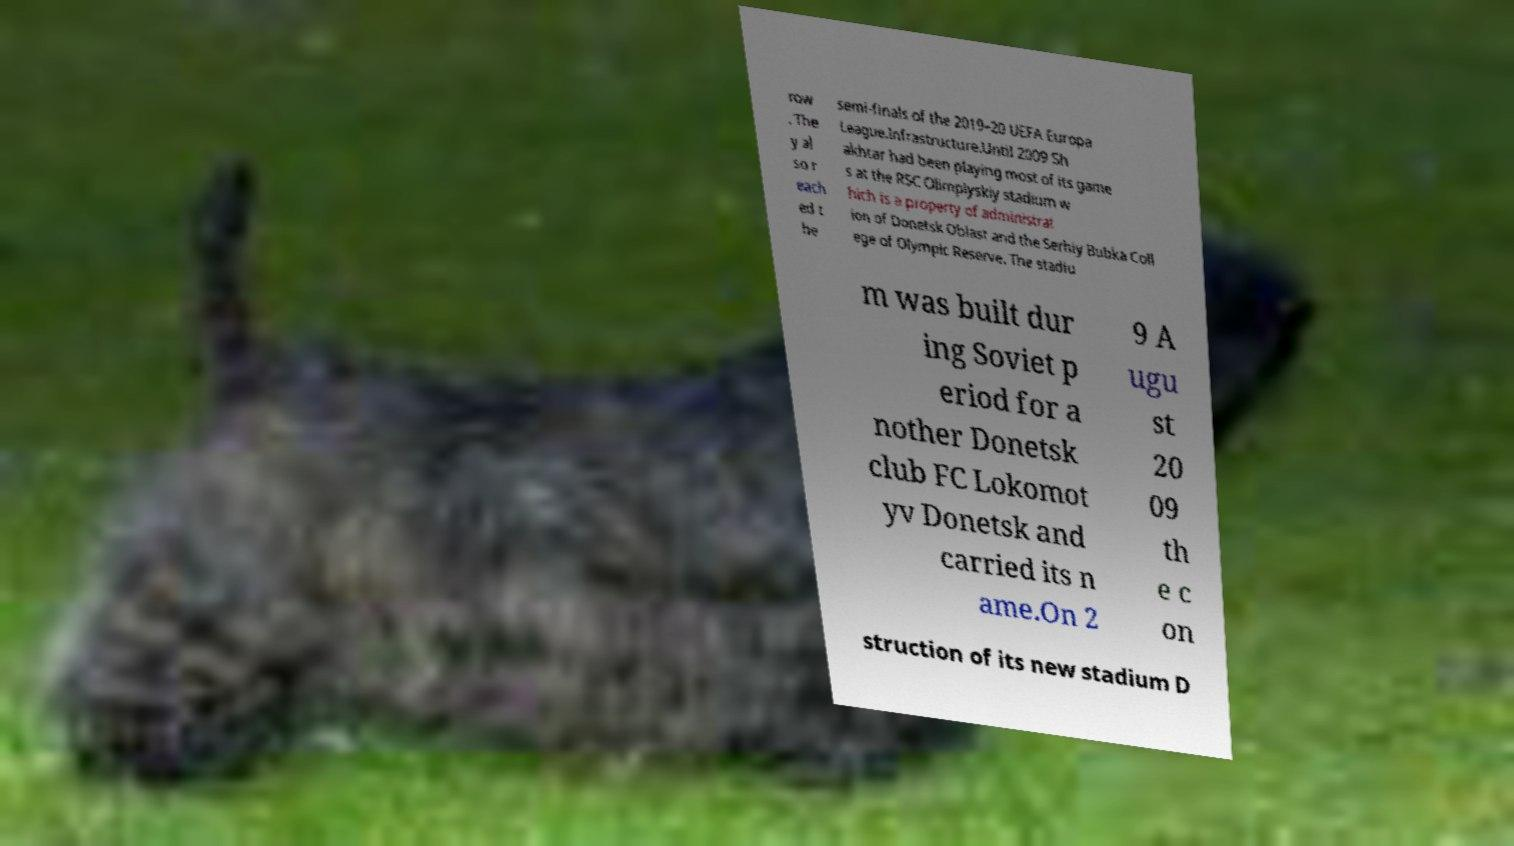Please read and relay the text visible in this image. What does it say? row . The y al so r each ed t he semi-finals of the 2019–20 UEFA Europa League.Infrastructure.Until 2009 Sh akhtar had been playing most of its game s at the RSC Olimpiyskiy stadium w hich is a property of administrat ion of Donetsk Oblast and the Serhiy Bubka Coll ege of Olympic Reserve. The stadiu m was built dur ing Soviet p eriod for a nother Donetsk club FC Lokomot yv Donetsk and carried its n ame.On 2 9 A ugu st 20 09 th e c on struction of its new stadium D 